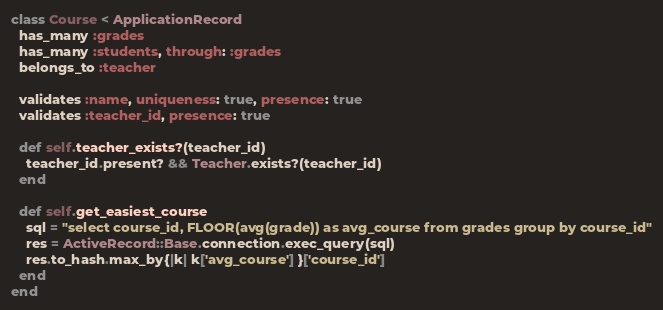Convert code to text. <code><loc_0><loc_0><loc_500><loc_500><_Ruby_>class Course < ApplicationRecord
  has_many :grades
  has_many :students, through: :grades
  belongs_to :teacher
  
  validates :name, uniqueness: true, presence: true
  validates :teacher_id, presence: true

  def self.teacher_exists?(teacher_id)
    teacher_id.present? && Teacher.exists?(teacher_id)
  end

  def self.get_easiest_course
    sql = "select course_id, FLOOR(avg(grade)) as avg_course from grades group by course_id"
    res = ActiveRecord::Base.connection.exec_query(sql)
    res.to_hash.max_by{|k| k['avg_course'] }['course_id']
  end
end
</code> 